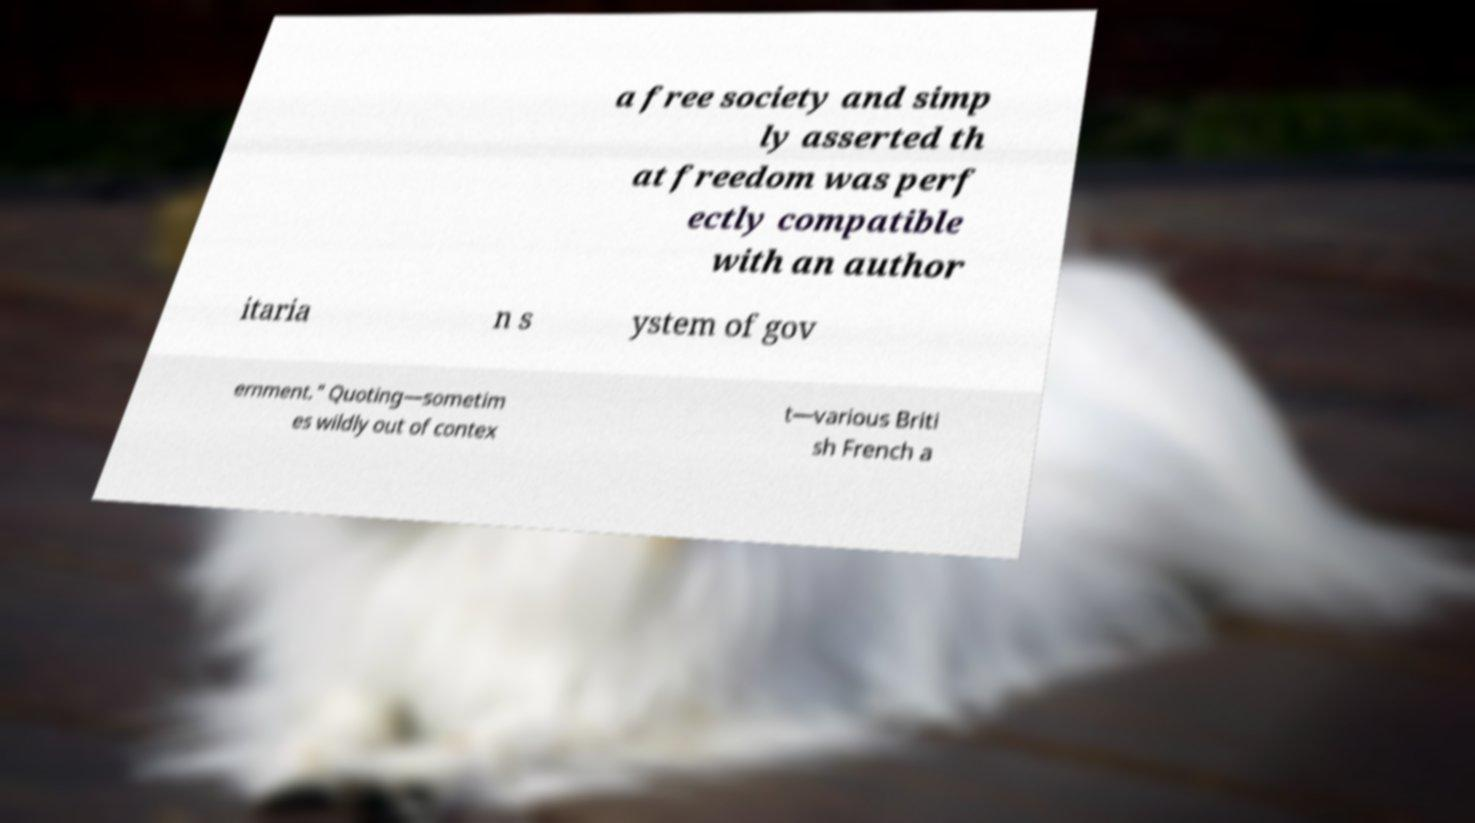Please read and relay the text visible in this image. What does it say? a free society and simp ly asserted th at freedom was perf ectly compatible with an author itaria n s ystem of gov ernment." Quoting—sometim es wildly out of contex t—various Briti sh French a 